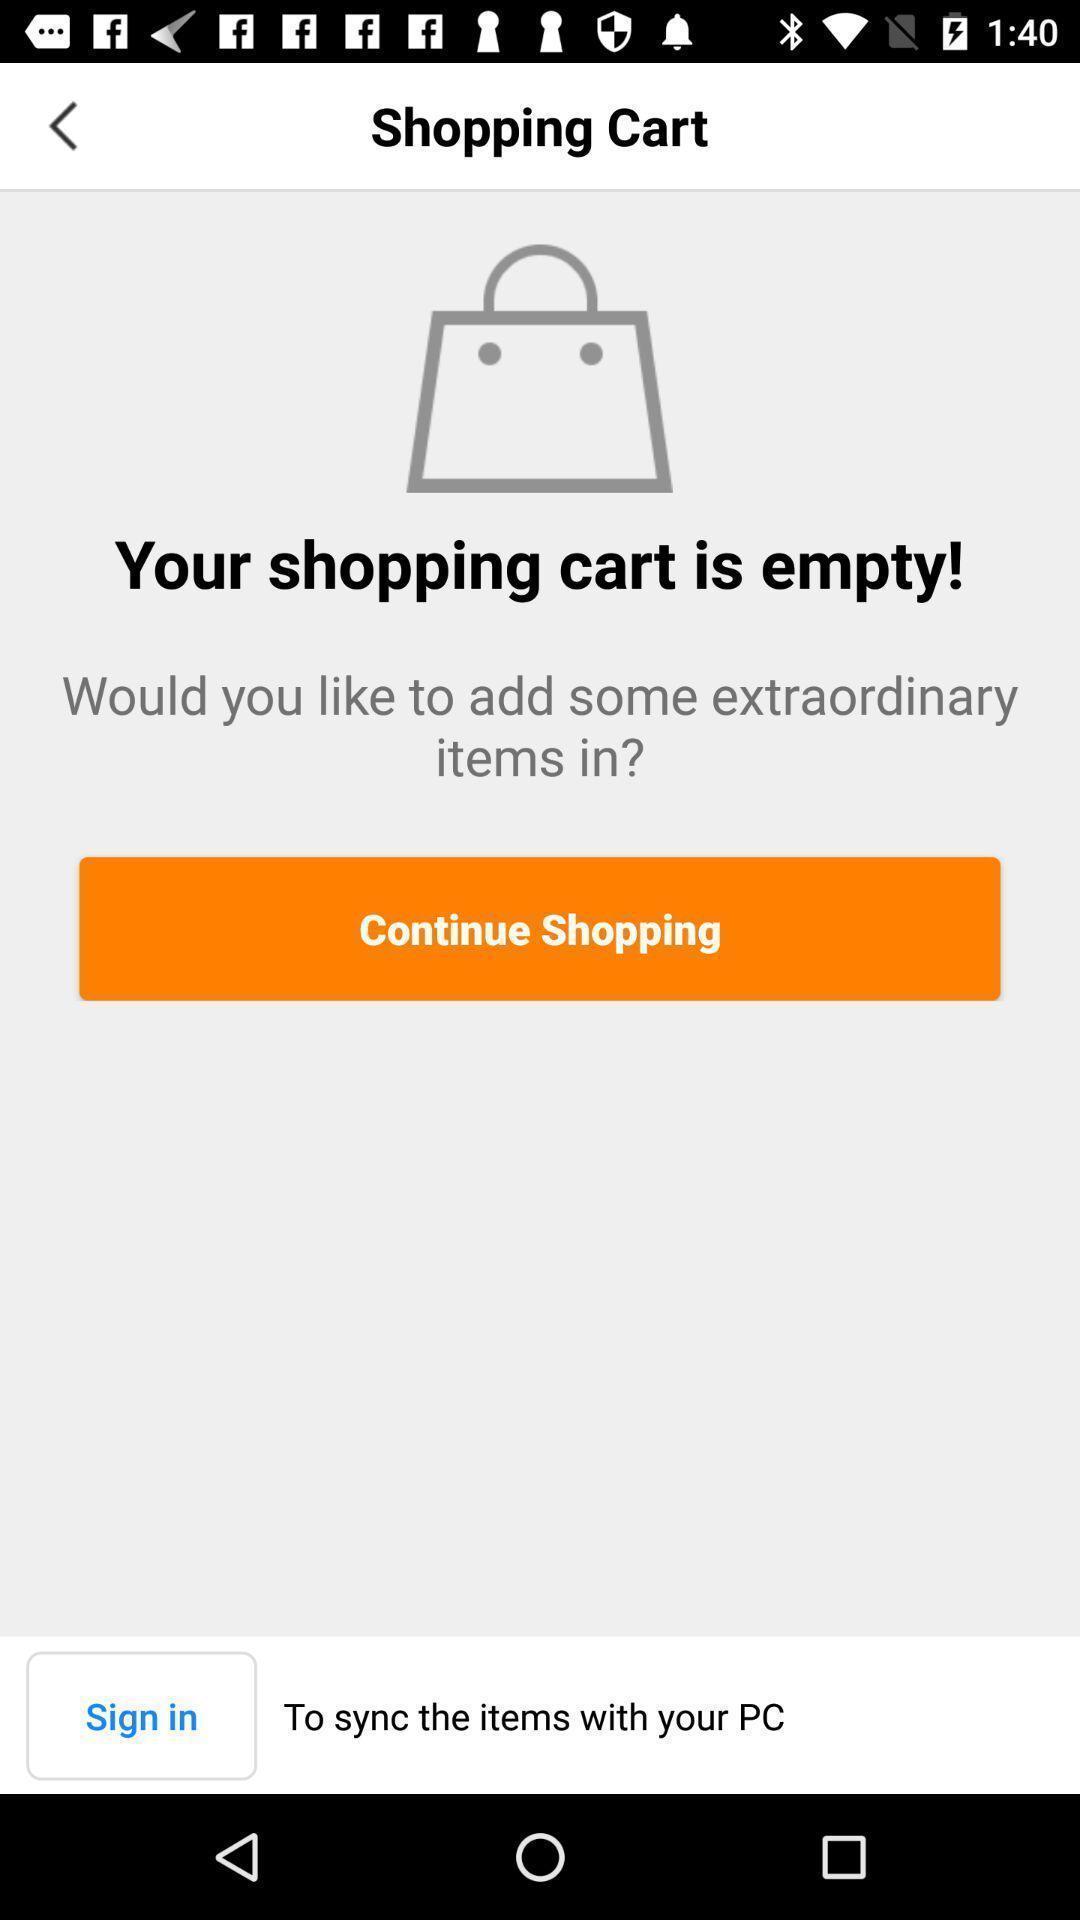Summarize the information in this screenshot. Sign in page of a shopping app. 